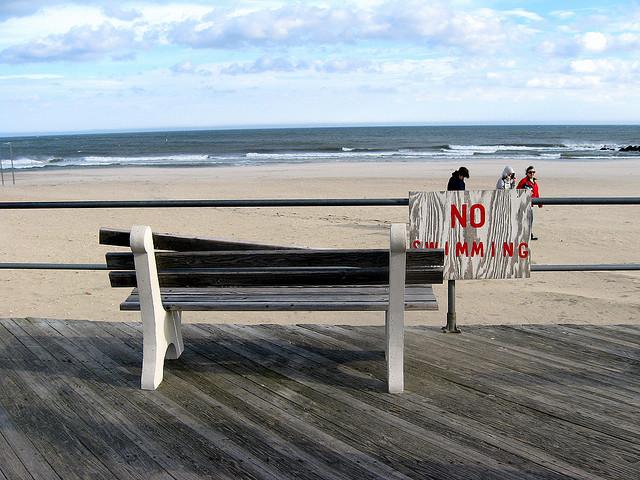How do you know it is cold in the photo?
Short answer required. Jackets. What is the object in the center?
Short answer required. Bench. How many people have their head covered?
Keep it brief. 2. Why is there a no swimming sign?
Write a very short answer. So people don't swim. 